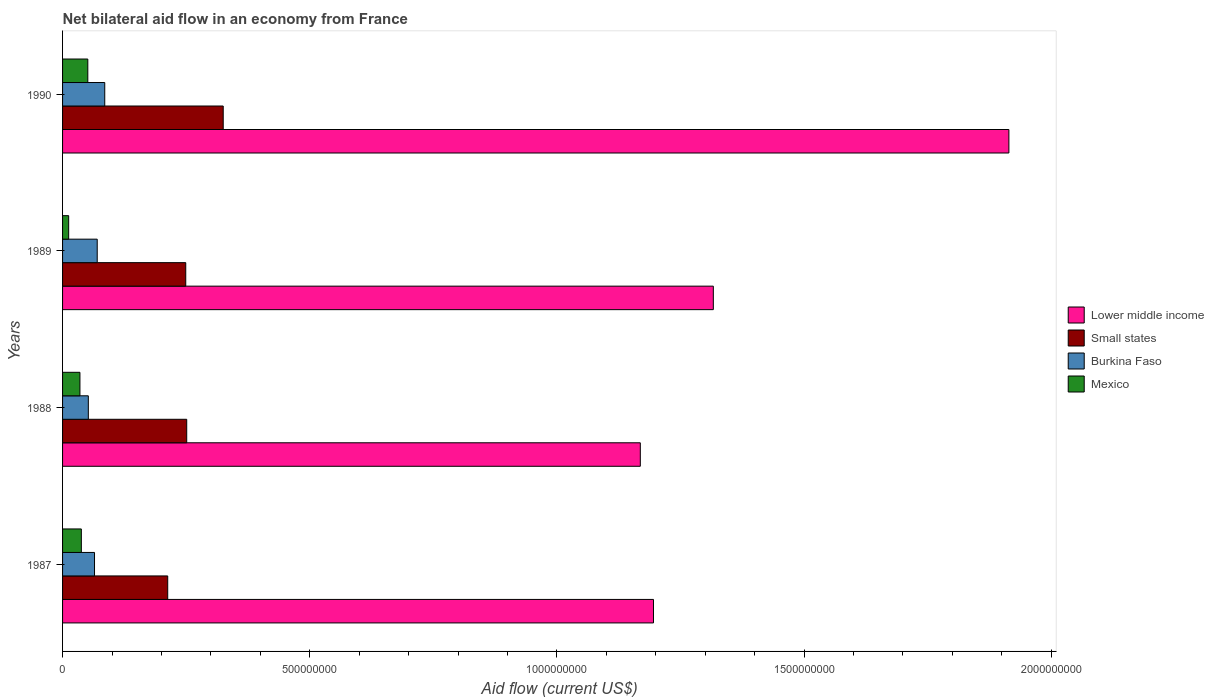How many different coloured bars are there?
Keep it short and to the point. 4. Are the number of bars per tick equal to the number of legend labels?
Provide a succinct answer. Yes. How many bars are there on the 2nd tick from the top?
Give a very brief answer. 4. In how many cases, is the number of bars for a given year not equal to the number of legend labels?
Offer a terse response. 0. What is the net bilateral aid flow in Small states in 1989?
Your response must be concise. 2.49e+08. Across all years, what is the maximum net bilateral aid flow in Small states?
Make the answer very short. 3.25e+08. Across all years, what is the minimum net bilateral aid flow in Small states?
Your answer should be compact. 2.13e+08. In which year was the net bilateral aid flow in Lower middle income minimum?
Your answer should be compact. 1988. What is the total net bilateral aid flow in Lower middle income in the graph?
Your answer should be very brief. 5.59e+09. What is the difference between the net bilateral aid flow in Lower middle income in 1989 and that in 1990?
Your answer should be very brief. -5.98e+08. What is the difference between the net bilateral aid flow in Burkina Faso in 1990 and the net bilateral aid flow in Small states in 1987?
Provide a short and direct response. -1.27e+08. What is the average net bilateral aid flow in Small states per year?
Keep it short and to the point. 2.60e+08. In the year 1990, what is the difference between the net bilateral aid flow in Burkina Faso and net bilateral aid flow in Mexico?
Give a very brief answer. 3.42e+07. In how many years, is the net bilateral aid flow in Burkina Faso greater than 1800000000 US$?
Provide a short and direct response. 0. What is the ratio of the net bilateral aid flow in Lower middle income in 1987 to that in 1989?
Your answer should be very brief. 0.91. Is the net bilateral aid flow in Lower middle income in 1989 less than that in 1990?
Ensure brevity in your answer.  Yes. Is the difference between the net bilateral aid flow in Burkina Faso in 1988 and 1989 greater than the difference between the net bilateral aid flow in Mexico in 1988 and 1989?
Offer a very short reply. No. What is the difference between the highest and the second highest net bilateral aid flow in Small states?
Provide a succinct answer. 7.39e+07. What is the difference between the highest and the lowest net bilateral aid flow in Mexico?
Offer a very short reply. 3.87e+07. What does the 3rd bar from the top in 1987 represents?
Provide a succinct answer. Small states. What does the 2nd bar from the bottom in 1989 represents?
Make the answer very short. Small states. Are all the bars in the graph horizontal?
Your response must be concise. Yes. How many years are there in the graph?
Make the answer very short. 4. Are the values on the major ticks of X-axis written in scientific E-notation?
Offer a terse response. No. Does the graph contain any zero values?
Offer a very short reply. No. Where does the legend appear in the graph?
Your response must be concise. Center right. How many legend labels are there?
Provide a succinct answer. 4. How are the legend labels stacked?
Keep it short and to the point. Vertical. What is the title of the graph?
Provide a short and direct response. Net bilateral aid flow in an economy from France. What is the label or title of the X-axis?
Provide a succinct answer. Aid flow (current US$). What is the Aid flow (current US$) in Lower middle income in 1987?
Keep it short and to the point. 1.20e+09. What is the Aid flow (current US$) of Small states in 1987?
Provide a short and direct response. 2.13e+08. What is the Aid flow (current US$) in Burkina Faso in 1987?
Provide a succinct answer. 6.46e+07. What is the Aid flow (current US$) of Mexico in 1987?
Your answer should be compact. 3.80e+07. What is the Aid flow (current US$) of Lower middle income in 1988?
Give a very brief answer. 1.17e+09. What is the Aid flow (current US$) of Small states in 1988?
Provide a succinct answer. 2.51e+08. What is the Aid flow (current US$) of Burkina Faso in 1988?
Make the answer very short. 5.21e+07. What is the Aid flow (current US$) of Mexico in 1988?
Your answer should be very brief. 3.51e+07. What is the Aid flow (current US$) in Lower middle income in 1989?
Your answer should be very brief. 1.32e+09. What is the Aid flow (current US$) in Small states in 1989?
Offer a very short reply. 2.49e+08. What is the Aid flow (current US$) of Burkina Faso in 1989?
Keep it short and to the point. 7.01e+07. What is the Aid flow (current US$) in Mexico in 1989?
Make the answer very short. 1.24e+07. What is the Aid flow (current US$) of Lower middle income in 1990?
Your answer should be compact. 1.91e+09. What is the Aid flow (current US$) of Small states in 1990?
Your response must be concise. 3.25e+08. What is the Aid flow (current US$) of Burkina Faso in 1990?
Ensure brevity in your answer.  8.53e+07. What is the Aid flow (current US$) of Mexico in 1990?
Offer a very short reply. 5.11e+07. Across all years, what is the maximum Aid flow (current US$) in Lower middle income?
Keep it short and to the point. 1.91e+09. Across all years, what is the maximum Aid flow (current US$) in Small states?
Offer a very short reply. 3.25e+08. Across all years, what is the maximum Aid flow (current US$) of Burkina Faso?
Give a very brief answer. 8.53e+07. Across all years, what is the maximum Aid flow (current US$) in Mexico?
Give a very brief answer. 5.11e+07. Across all years, what is the minimum Aid flow (current US$) of Lower middle income?
Make the answer very short. 1.17e+09. Across all years, what is the minimum Aid flow (current US$) in Small states?
Offer a very short reply. 2.13e+08. Across all years, what is the minimum Aid flow (current US$) of Burkina Faso?
Provide a succinct answer. 5.21e+07. Across all years, what is the minimum Aid flow (current US$) of Mexico?
Provide a short and direct response. 1.24e+07. What is the total Aid flow (current US$) of Lower middle income in the graph?
Provide a short and direct response. 5.59e+09. What is the total Aid flow (current US$) in Small states in the graph?
Offer a very short reply. 1.04e+09. What is the total Aid flow (current US$) in Burkina Faso in the graph?
Your response must be concise. 2.72e+08. What is the total Aid flow (current US$) in Mexico in the graph?
Your answer should be very brief. 1.37e+08. What is the difference between the Aid flow (current US$) of Lower middle income in 1987 and that in 1988?
Provide a succinct answer. 2.66e+07. What is the difference between the Aid flow (current US$) of Small states in 1987 and that in 1988?
Give a very brief answer. -3.84e+07. What is the difference between the Aid flow (current US$) in Burkina Faso in 1987 and that in 1988?
Your answer should be very brief. 1.25e+07. What is the difference between the Aid flow (current US$) of Mexico in 1987 and that in 1988?
Make the answer very short. 2.85e+06. What is the difference between the Aid flow (current US$) in Lower middle income in 1987 and that in 1989?
Make the answer very short. -1.21e+08. What is the difference between the Aid flow (current US$) of Small states in 1987 and that in 1989?
Offer a terse response. -3.65e+07. What is the difference between the Aid flow (current US$) of Burkina Faso in 1987 and that in 1989?
Ensure brevity in your answer.  -5.47e+06. What is the difference between the Aid flow (current US$) of Mexico in 1987 and that in 1989?
Provide a succinct answer. 2.56e+07. What is the difference between the Aid flow (current US$) of Lower middle income in 1987 and that in 1990?
Provide a succinct answer. -7.19e+08. What is the difference between the Aid flow (current US$) of Small states in 1987 and that in 1990?
Your response must be concise. -1.12e+08. What is the difference between the Aid flow (current US$) of Burkina Faso in 1987 and that in 1990?
Provide a short and direct response. -2.07e+07. What is the difference between the Aid flow (current US$) in Mexico in 1987 and that in 1990?
Provide a succinct answer. -1.31e+07. What is the difference between the Aid flow (current US$) of Lower middle income in 1988 and that in 1989?
Ensure brevity in your answer.  -1.48e+08. What is the difference between the Aid flow (current US$) in Small states in 1988 and that in 1989?
Provide a short and direct response. 1.95e+06. What is the difference between the Aid flow (current US$) in Burkina Faso in 1988 and that in 1989?
Ensure brevity in your answer.  -1.80e+07. What is the difference between the Aid flow (current US$) of Mexico in 1988 and that in 1989?
Your answer should be very brief. 2.28e+07. What is the difference between the Aid flow (current US$) of Lower middle income in 1988 and that in 1990?
Ensure brevity in your answer.  -7.46e+08. What is the difference between the Aid flow (current US$) of Small states in 1988 and that in 1990?
Ensure brevity in your answer.  -7.39e+07. What is the difference between the Aid flow (current US$) of Burkina Faso in 1988 and that in 1990?
Ensure brevity in your answer.  -3.32e+07. What is the difference between the Aid flow (current US$) in Mexico in 1988 and that in 1990?
Offer a terse response. -1.59e+07. What is the difference between the Aid flow (current US$) of Lower middle income in 1989 and that in 1990?
Ensure brevity in your answer.  -5.98e+08. What is the difference between the Aid flow (current US$) in Small states in 1989 and that in 1990?
Offer a very short reply. -7.58e+07. What is the difference between the Aid flow (current US$) in Burkina Faso in 1989 and that in 1990?
Make the answer very short. -1.52e+07. What is the difference between the Aid flow (current US$) of Mexico in 1989 and that in 1990?
Give a very brief answer. -3.87e+07. What is the difference between the Aid flow (current US$) of Lower middle income in 1987 and the Aid flow (current US$) of Small states in 1988?
Offer a terse response. 9.44e+08. What is the difference between the Aid flow (current US$) in Lower middle income in 1987 and the Aid flow (current US$) in Burkina Faso in 1988?
Keep it short and to the point. 1.14e+09. What is the difference between the Aid flow (current US$) of Lower middle income in 1987 and the Aid flow (current US$) of Mexico in 1988?
Give a very brief answer. 1.16e+09. What is the difference between the Aid flow (current US$) in Small states in 1987 and the Aid flow (current US$) in Burkina Faso in 1988?
Keep it short and to the point. 1.61e+08. What is the difference between the Aid flow (current US$) of Small states in 1987 and the Aid flow (current US$) of Mexico in 1988?
Your answer should be very brief. 1.78e+08. What is the difference between the Aid flow (current US$) in Burkina Faso in 1987 and the Aid flow (current US$) in Mexico in 1988?
Your response must be concise. 2.95e+07. What is the difference between the Aid flow (current US$) in Lower middle income in 1987 and the Aid flow (current US$) in Small states in 1989?
Make the answer very short. 9.46e+08. What is the difference between the Aid flow (current US$) in Lower middle income in 1987 and the Aid flow (current US$) in Burkina Faso in 1989?
Provide a short and direct response. 1.13e+09. What is the difference between the Aid flow (current US$) in Lower middle income in 1987 and the Aid flow (current US$) in Mexico in 1989?
Your answer should be compact. 1.18e+09. What is the difference between the Aid flow (current US$) of Small states in 1987 and the Aid flow (current US$) of Burkina Faso in 1989?
Offer a terse response. 1.43e+08. What is the difference between the Aid flow (current US$) of Small states in 1987 and the Aid flow (current US$) of Mexico in 1989?
Your response must be concise. 2.00e+08. What is the difference between the Aid flow (current US$) of Burkina Faso in 1987 and the Aid flow (current US$) of Mexico in 1989?
Provide a short and direct response. 5.23e+07. What is the difference between the Aid flow (current US$) of Lower middle income in 1987 and the Aid flow (current US$) of Small states in 1990?
Your answer should be very brief. 8.70e+08. What is the difference between the Aid flow (current US$) in Lower middle income in 1987 and the Aid flow (current US$) in Burkina Faso in 1990?
Ensure brevity in your answer.  1.11e+09. What is the difference between the Aid flow (current US$) of Lower middle income in 1987 and the Aid flow (current US$) of Mexico in 1990?
Your answer should be compact. 1.14e+09. What is the difference between the Aid flow (current US$) in Small states in 1987 and the Aid flow (current US$) in Burkina Faso in 1990?
Provide a succinct answer. 1.27e+08. What is the difference between the Aid flow (current US$) of Small states in 1987 and the Aid flow (current US$) of Mexico in 1990?
Keep it short and to the point. 1.62e+08. What is the difference between the Aid flow (current US$) of Burkina Faso in 1987 and the Aid flow (current US$) of Mexico in 1990?
Your answer should be very brief. 1.36e+07. What is the difference between the Aid flow (current US$) of Lower middle income in 1988 and the Aid flow (current US$) of Small states in 1989?
Offer a terse response. 9.20e+08. What is the difference between the Aid flow (current US$) in Lower middle income in 1988 and the Aid flow (current US$) in Burkina Faso in 1989?
Provide a short and direct response. 1.10e+09. What is the difference between the Aid flow (current US$) of Lower middle income in 1988 and the Aid flow (current US$) of Mexico in 1989?
Offer a terse response. 1.16e+09. What is the difference between the Aid flow (current US$) in Small states in 1988 and the Aid flow (current US$) in Burkina Faso in 1989?
Make the answer very short. 1.81e+08. What is the difference between the Aid flow (current US$) of Small states in 1988 and the Aid flow (current US$) of Mexico in 1989?
Give a very brief answer. 2.39e+08. What is the difference between the Aid flow (current US$) of Burkina Faso in 1988 and the Aid flow (current US$) of Mexico in 1989?
Offer a very short reply. 3.98e+07. What is the difference between the Aid flow (current US$) in Lower middle income in 1988 and the Aid flow (current US$) in Small states in 1990?
Offer a very short reply. 8.44e+08. What is the difference between the Aid flow (current US$) in Lower middle income in 1988 and the Aid flow (current US$) in Burkina Faso in 1990?
Ensure brevity in your answer.  1.08e+09. What is the difference between the Aid flow (current US$) of Lower middle income in 1988 and the Aid flow (current US$) of Mexico in 1990?
Provide a succinct answer. 1.12e+09. What is the difference between the Aid flow (current US$) of Small states in 1988 and the Aid flow (current US$) of Burkina Faso in 1990?
Your response must be concise. 1.66e+08. What is the difference between the Aid flow (current US$) of Small states in 1988 and the Aid flow (current US$) of Mexico in 1990?
Give a very brief answer. 2.00e+08. What is the difference between the Aid flow (current US$) of Burkina Faso in 1988 and the Aid flow (current US$) of Mexico in 1990?
Your answer should be very brief. 1.05e+06. What is the difference between the Aid flow (current US$) of Lower middle income in 1989 and the Aid flow (current US$) of Small states in 1990?
Provide a short and direct response. 9.91e+08. What is the difference between the Aid flow (current US$) in Lower middle income in 1989 and the Aid flow (current US$) in Burkina Faso in 1990?
Provide a succinct answer. 1.23e+09. What is the difference between the Aid flow (current US$) of Lower middle income in 1989 and the Aid flow (current US$) of Mexico in 1990?
Provide a succinct answer. 1.27e+09. What is the difference between the Aid flow (current US$) in Small states in 1989 and the Aid flow (current US$) in Burkina Faso in 1990?
Your response must be concise. 1.64e+08. What is the difference between the Aid flow (current US$) of Small states in 1989 and the Aid flow (current US$) of Mexico in 1990?
Give a very brief answer. 1.98e+08. What is the difference between the Aid flow (current US$) of Burkina Faso in 1989 and the Aid flow (current US$) of Mexico in 1990?
Give a very brief answer. 1.90e+07. What is the average Aid flow (current US$) in Lower middle income per year?
Offer a terse response. 1.40e+09. What is the average Aid flow (current US$) of Small states per year?
Provide a short and direct response. 2.60e+08. What is the average Aid flow (current US$) in Burkina Faso per year?
Offer a very short reply. 6.80e+07. What is the average Aid flow (current US$) in Mexico per year?
Keep it short and to the point. 3.41e+07. In the year 1987, what is the difference between the Aid flow (current US$) of Lower middle income and Aid flow (current US$) of Small states?
Offer a terse response. 9.83e+08. In the year 1987, what is the difference between the Aid flow (current US$) in Lower middle income and Aid flow (current US$) in Burkina Faso?
Keep it short and to the point. 1.13e+09. In the year 1987, what is the difference between the Aid flow (current US$) in Lower middle income and Aid flow (current US$) in Mexico?
Provide a short and direct response. 1.16e+09. In the year 1987, what is the difference between the Aid flow (current US$) in Small states and Aid flow (current US$) in Burkina Faso?
Keep it short and to the point. 1.48e+08. In the year 1987, what is the difference between the Aid flow (current US$) of Small states and Aid flow (current US$) of Mexico?
Your answer should be compact. 1.75e+08. In the year 1987, what is the difference between the Aid flow (current US$) in Burkina Faso and Aid flow (current US$) in Mexico?
Provide a succinct answer. 2.66e+07. In the year 1988, what is the difference between the Aid flow (current US$) in Lower middle income and Aid flow (current US$) in Small states?
Offer a very short reply. 9.18e+08. In the year 1988, what is the difference between the Aid flow (current US$) of Lower middle income and Aid flow (current US$) of Burkina Faso?
Your answer should be very brief. 1.12e+09. In the year 1988, what is the difference between the Aid flow (current US$) of Lower middle income and Aid flow (current US$) of Mexico?
Your answer should be compact. 1.13e+09. In the year 1988, what is the difference between the Aid flow (current US$) of Small states and Aid flow (current US$) of Burkina Faso?
Make the answer very short. 1.99e+08. In the year 1988, what is the difference between the Aid flow (current US$) of Small states and Aid flow (current US$) of Mexico?
Provide a short and direct response. 2.16e+08. In the year 1988, what is the difference between the Aid flow (current US$) of Burkina Faso and Aid flow (current US$) of Mexico?
Offer a very short reply. 1.70e+07. In the year 1989, what is the difference between the Aid flow (current US$) in Lower middle income and Aid flow (current US$) in Small states?
Offer a very short reply. 1.07e+09. In the year 1989, what is the difference between the Aid flow (current US$) of Lower middle income and Aid flow (current US$) of Burkina Faso?
Keep it short and to the point. 1.25e+09. In the year 1989, what is the difference between the Aid flow (current US$) of Lower middle income and Aid flow (current US$) of Mexico?
Give a very brief answer. 1.30e+09. In the year 1989, what is the difference between the Aid flow (current US$) of Small states and Aid flow (current US$) of Burkina Faso?
Your answer should be compact. 1.79e+08. In the year 1989, what is the difference between the Aid flow (current US$) in Small states and Aid flow (current US$) in Mexico?
Keep it short and to the point. 2.37e+08. In the year 1989, what is the difference between the Aid flow (current US$) of Burkina Faso and Aid flow (current US$) of Mexico?
Give a very brief answer. 5.77e+07. In the year 1990, what is the difference between the Aid flow (current US$) in Lower middle income and Aid flow (current US$) in Small states?
Make the answer very short. 1.59e+09. In the year 1990, what is the difference between the Aid flow (current US$) in Lower middle income and Aid flow (current US$) in Burkina Faso?
Offer a terse response. 1.83e+09. In the year 1990, what is the difference between the Aid flow (current US$) of Lower middle income and Aid flow (current US$) of Mexico?
Your answer should be compact. 1.86e+09. In the year 1990, what is the difference between the Aid flow (current US$) of Small states and Aid flow (current US$) of Burkina Faso?
Your answer should be compact. 2.40e+08. In the year 1990, what is the difference between the Aid flow (current US$) of Small states and Aid flow (current US$) of Mexico?
Your answer should be compact. 2.74e+08. In the year 1990, what is the difference between the Aid flow (current US$) of Burkina Faso and Aid flow (current US$) of Mexico?
Offer a very short reply. 3.42e+07. What is the ratio of the Aid flow (current US$) in Lower middle income in 1987 to that in 1988?
Ensure brevity in your answer.  1.02. What is the ratio of the Aid flow (current US$) of Small states in 1987 to that in 1988?
Provide a succinct answer. 0.85. What is the ratio of the Aid flow (current US$) in Burkina Faso in 1987 to that in 1988?
Your answer should be very brief. 1.24. What is the ratio of the Aid flow (current US$) of Mexico in 1987 to that in 1988?
Make the answer very short. 1.08. What is the ratio of the Aid flow (current US$) of Lower middle income in 1987 to that in 1989?
Offer a very short reply. 0.91. What is the ratio of the Aid flow (current US$) in Small states in 1987 to that in 1989?
Provide a short and direct response. 0.85. What is the ratio of the Aid flow (current US$) in Burkina Faso in 1987 to that in 1989?
Your response must be concise. 0.92. What is the ratio of the Aid flow (current US$) in Mexico in 1987 to that in 1989?
Your response must be concise. 3.07. What is the ratio of the Aid flow (current US$) of Lower middle income in 1987 to that in 1990?
Offer a very short reply. 0.62. What is the ratio of the Aid flow (current US$) of Small states in 1987 to that in 1990?
Keep it short and to the point. 0.65. What is the ratio of the Aid flow (current US$) in Burkina Faso in 1987 to that in 1990?
Offer a very short reply. 0.76. What is the ratio of the Aid flow (current US$) in Mexico in 1987 to that in 1990?
Give a very brief answer. 0.74. What is the ratio of the Aid flow (current US$) in Lower middle income in 1988 to that in 1989?
Offer a terse response. 0.89. What is the ratio of the Aid flow (current US$) of Small states in 1988 to that in 1989?
Ensure brevity in your answer.  1.01. What is the ratio of the Aid flow (current US$) in Burkina Faso in 1988 to that in 1989?
Offer a terse response. 0.74. What is the ratio of the Aid flow (current US$) of Mexico in 1988 to that in 1989?
Offer a terse response. 2.84. What is the ratio of the Aid flow (current US$) in Lower middle income in 1988 to that in 1990?
Provide a short and direct response. 0.61. What is the ratio of the Aid flow (current US$) in Small states in 1988 to that in 1990?
Provide a short and direct response. 0.77. What is the ratio of the Aid flow (current US$) of Burkina Faso in 1988 to that in 1990?
Ensure brevity in your answer.  0.61. What is the ratio of the Aid flow (current US$) of Mexico in 1988 to that in 1990?
Make the answer very short. 0.69. What is the ratio of the Aid flow (current US$) in Lower middle income in 1989 to that in 1990?
Ensure brevity in your answer.  0.69. What is the ratio of the Aid flow (current US$) of Small states in 1989 to that in 1990?
Your answer should be very brief. 0.77. What is the ratio of the Aid flow (current US$) of Burkina Faso in 1989 to that in 1990?
Your response must be concise. 0.82. What is the ratio of the Aid flow (current US$) of Mexico in 1989 to that in 1990?
Make the answer very short. 0.24. What is the difference between the highest and the second highest Aid flow (current US$) in Lower middle income?
Your response must be concise. 5.98e+08. What is the difference between the highest and the second highest Aid flow (current US$) of Small states?
Your answer should be compact. 7.39e+07. What is the difference between the highest and the second highest Aid flow (current US$) of Burkina Faso?
Keep it short and to the point. 1.52e+07. What is the difference between the highest and the second highest Aid flow (current US$) of Mexico?
Provide a succinct answer. 1.31e+07. What is the difference between the highest and the lowest Aid flow (current US$) of Lower middle income?
Offer a very short reply. 7.46e+08. What is the difference between the highest and the lowest Aid flow (current US$) of Small states?
Provide a succinct answer. 1.12e+08. What is the difference between the highest and the lowest Aid flow (current US$) in Burkina Faso?
Your answer should be compact. 3.32e+07. What is the difference between the highest and the lowest Aid flow (current US$) of Mexico?
Give a very brief answer. 3.87e+07. 